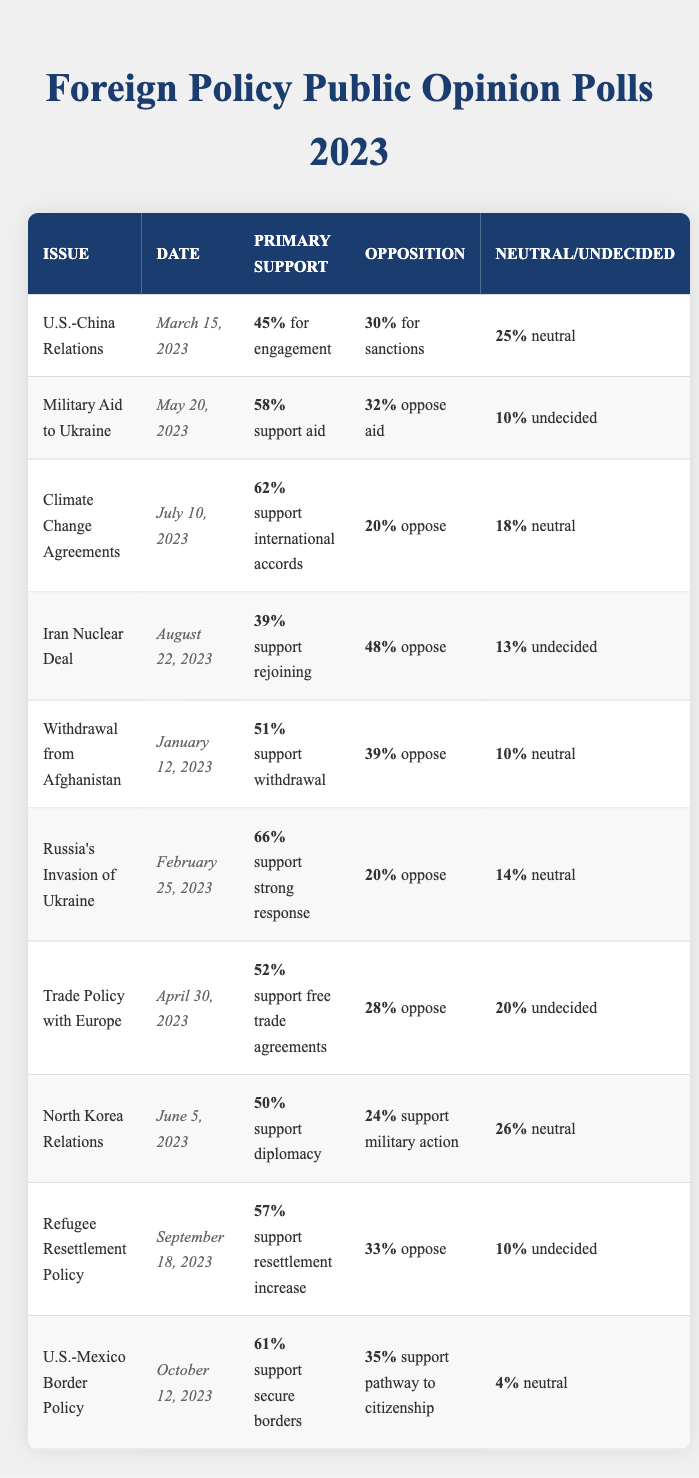What percentage of people supported Military Aid to Ukraine in the poll conducted on May 20, 2023? The table shows that for the issue of Military Aid to Ukraine, the support for aid was 58% according to the data from May 20, 2023.
Answer: 58% What was the opposition percentage for the Iran Nuclear Deal on August 22, 2023? The table lists the opposition percentage for the Iran Nuclear Deal on August 22, 2023, as 48%.
Answer: 48% Was there a higher percentage of support for Climate Change Agreements or Refugee Resettlement Policy? According to the table, support for Climate Change Agreements was 62%, while support for Refugee Resettlement Policy was 57%. Thus, support for Climate Change Agreements was higher.
Answer: Yes What is the neutral percentage for U.S.-Mexico Border Policy? In the table, it is indicated that the neutral percentage for U.S.-Mexico Border Policy is 4%.
Answer: 4% Which foreign policy issue had the highest support for a strong response according to the polls? The data suggests that for Russia's Invasion of Ukraine, there was a support for a strong response at 66%, which is the highest among all listed issues.
Answer: Russia's Invasion of Ukraine What is the difference in percentage between support and opposition for North Korea Relations? The support for North Korea Relations was 50% and the support for military action (which can be considered as opposition) was 24%, making the difference 50% - 24% = 26%.
Answer: 26% How many issues had a support percentage above 60%? From the table, there are two issues where the support percentage is above 60%: Climate Change Agreements (62%) and Russia's Invasion of Ukraine (66%). Therefore, there are two such issues.
Answer: 2 What are the percentages of support for secure borders and support for a pathway to citizenship in the U.S.-Mexico Border Policy? The support for secure borders is 61%, while support for a pathway to citizenship is 35%, as indicated in the table for the U.S.-Mexico Border Policy.
Answer: 61% and 35% Did more people oppose the Withdrawal from Afghanistan than support it? According to the data, 39% opposed the Withdrawal from Afghanistan while 51% supported it, which means that more people supported it than opposed it.
Answer: No 